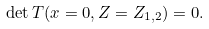Convert formula to latex. <formula><loc_0><loc_0><loc_500><loc_500>\det T ( x = 0 , Z = Z _ { 1 , 2 } ) = 0 .</formula> 